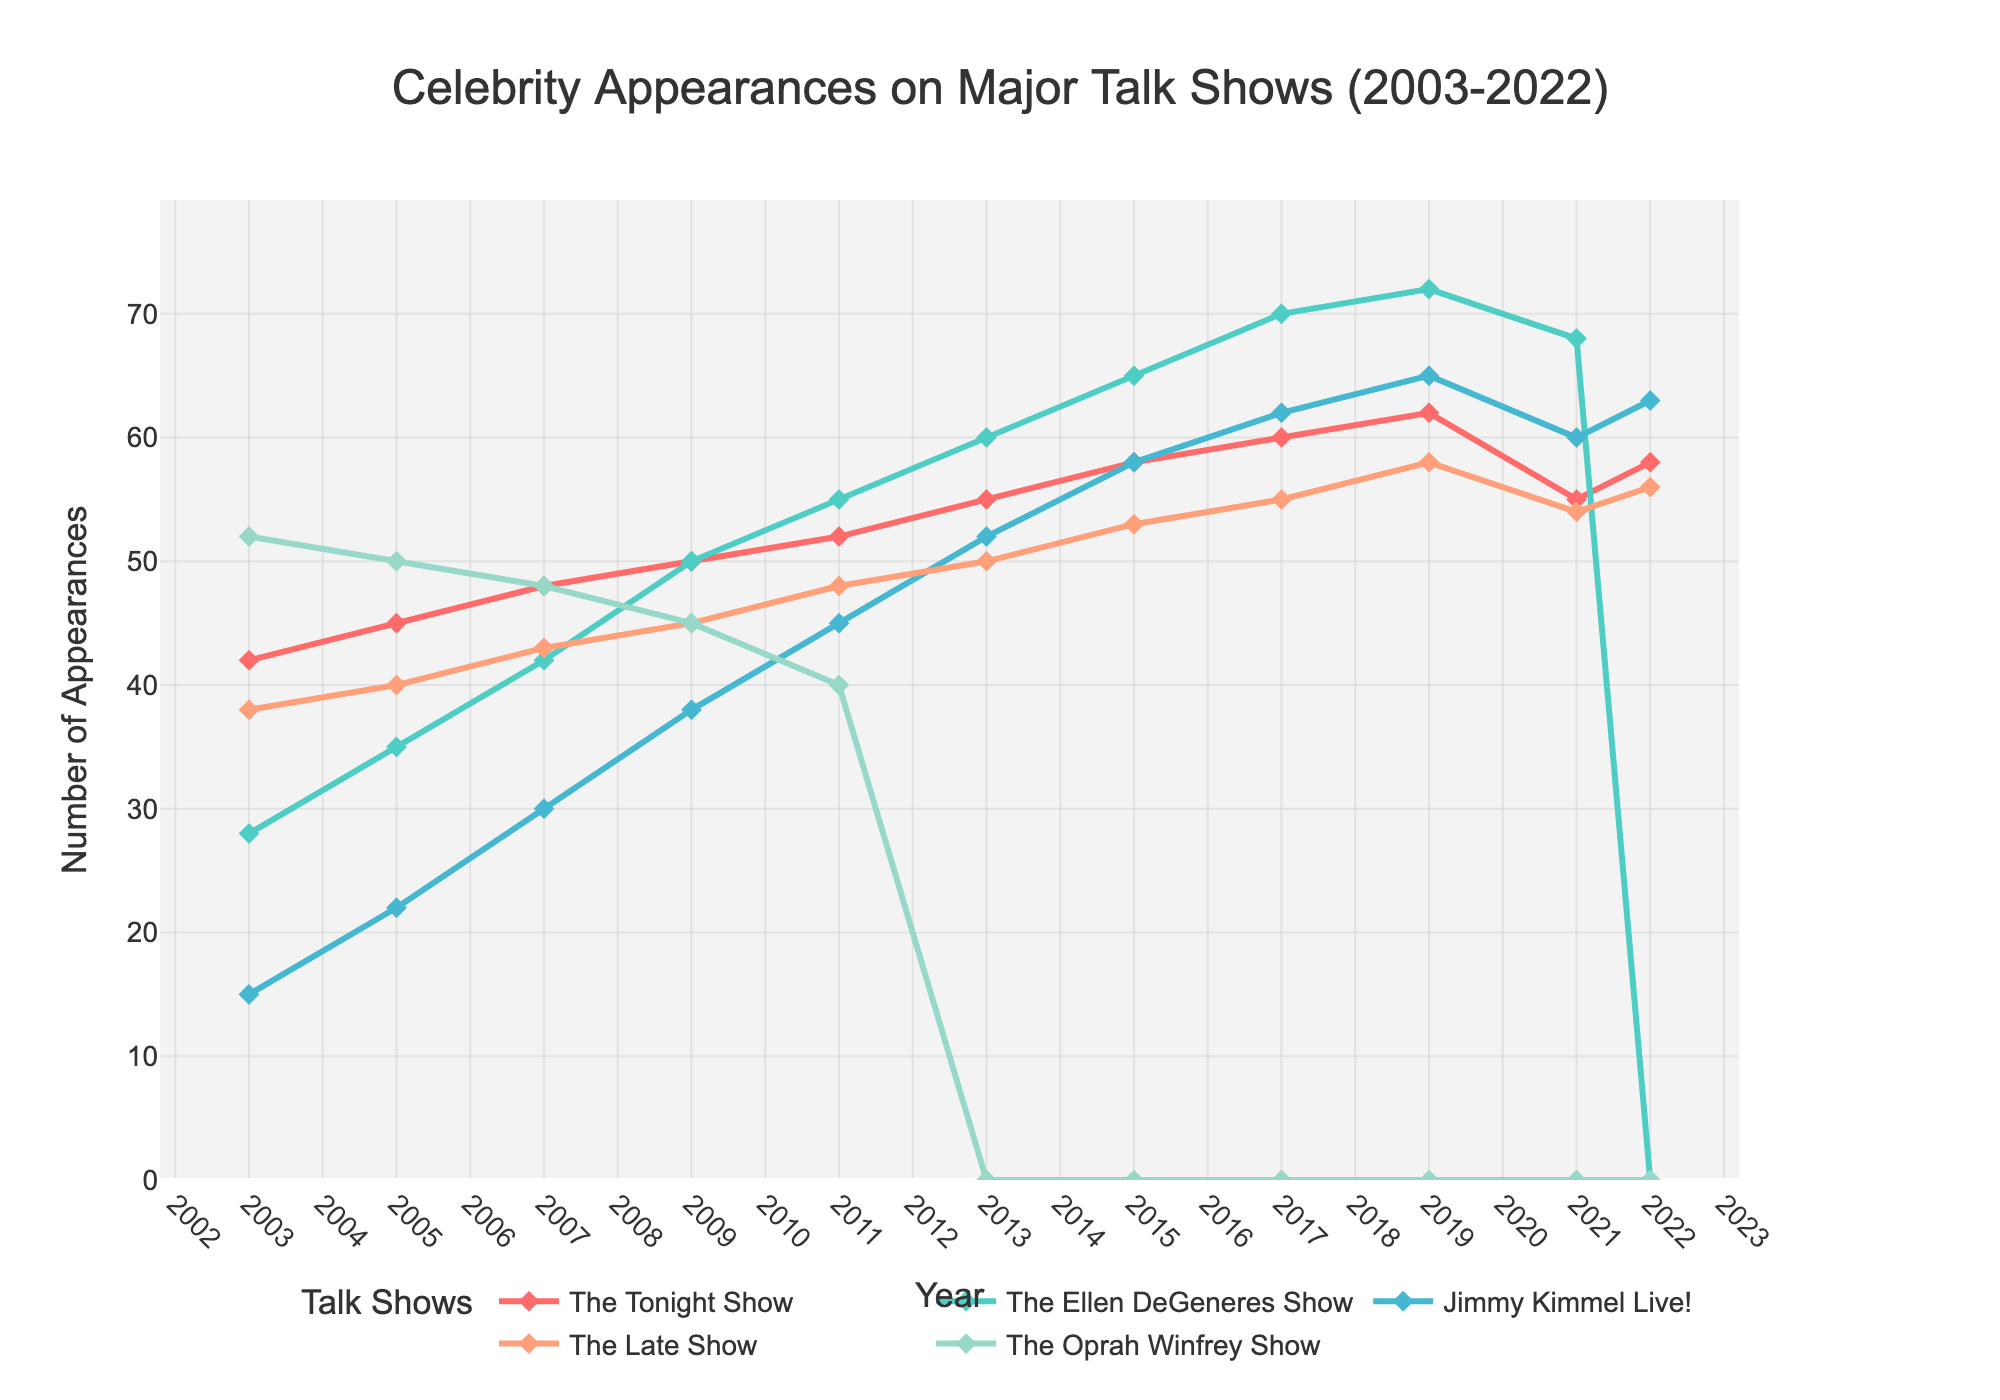What year had the highest number of celebrity appearances on "The Ellen DeGeneres Show"? By inspecting the figure, locate the peak on the line representing "The Ellen DeGeneres Show." The peak occurs in 2019 with 72 appearances.
Answer: 2019 By how much did the number of appearances on "Jimmy Kimmel Live!" increase from 2005 to 2011? Identify the values for "Jimmy Kimmel Live!" in 2005 and 2011, then calculate the difference: 45 (2011) - 22 (2005) = 23.
Answer: 23 Which talk show had the most appearances in 2009, and how many appearances were there? In 2009, "The Tonight Show" had 50 appearances, "The Ellen DeGeneres Show" had 50, "Jimmy Kimmel Live!" had 38, "The Late Show" had 45, and "The Oprah Winfrey Show" had 45. The highest was "The Tonight Show" and "The Ellen DeGeneres Show," both with 50 appearances.
Answer: "The Tonight Show" and "The Ellen DeGeneres Show"; 50 What is the overall trend observed in the appearances on "The Oprah Winfrey Show"? Observe the line for "The Oprah Winfrey Show," which shows a steady decline until 2013 when it drops to zero, indicating the end of the show.
Answer: Declining until it stops in 2013 How much higher was "The Tonight Show" appearances in 2017 compared to "The Late Show" in the same year? Compare the appearances for "The Tonight Show" and "The Late Show" in 2017, calculate the difference: 60 (The Tonight Show) - 55 (The Late Show) = 5.
Answer: 5 Which year did "The Ellen DeGeneres Show" see its highest number of celebrity appearances? Locate the maximum point on the "The Ellen DeGeneres Show" line, which occurred in 2019 with 72 appearances.
Answer: 2019 Compare the total number of appearances on "The Tonight Show" versus "The Late Show" in 2022. In 2022, "The Tonight Show" had 58 appearances and "The Late Show" had 56. The difference is 58 - 56 = 2.
Answer: 2 What's the average number of appearances on "The Tonight Show" over the entire plotted period? Sum the appearances each year [(42+45+48+50+52+55+58+60+62+55+58) = 585], then divide by the number of years (11): 585 / 11 ≈ 53.18.
Answer: ~53.18 By what percentage did the appearances on "Jimmy Kimmel Live!" increase from 2003 to 2019? Calculate the initial and final values for "Jimmy Kimmel Live!" and use the percentage increase formula [(65-15)/15] * 100 = 333.33%.
Answer: 333.33% What is the visual clue indicating the end of "The Oprah Winfrey Show"? The line for "The Oprah Winfrey Show" drops to zero in 2013 and remains absent, showing the show's end.
Answer: Line drops to zero and disappears 